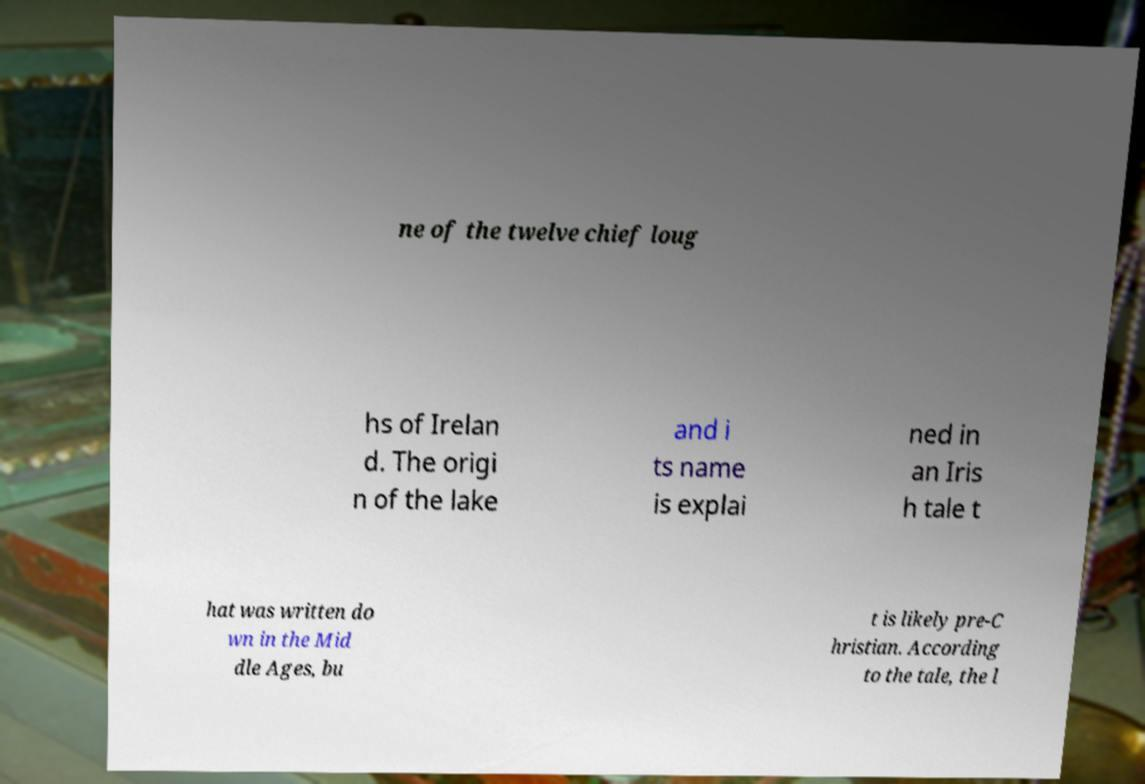Can you accurately transcribe the text from the provided image for me? ne of the twelve chief loug hs of Irelan d. The origi n of the lake and i ts name is explai ned in an Iris h tale t hat was written do wn in the Mid dle Ages, bu t is likely pre-C hristian. According to the tale, the l 